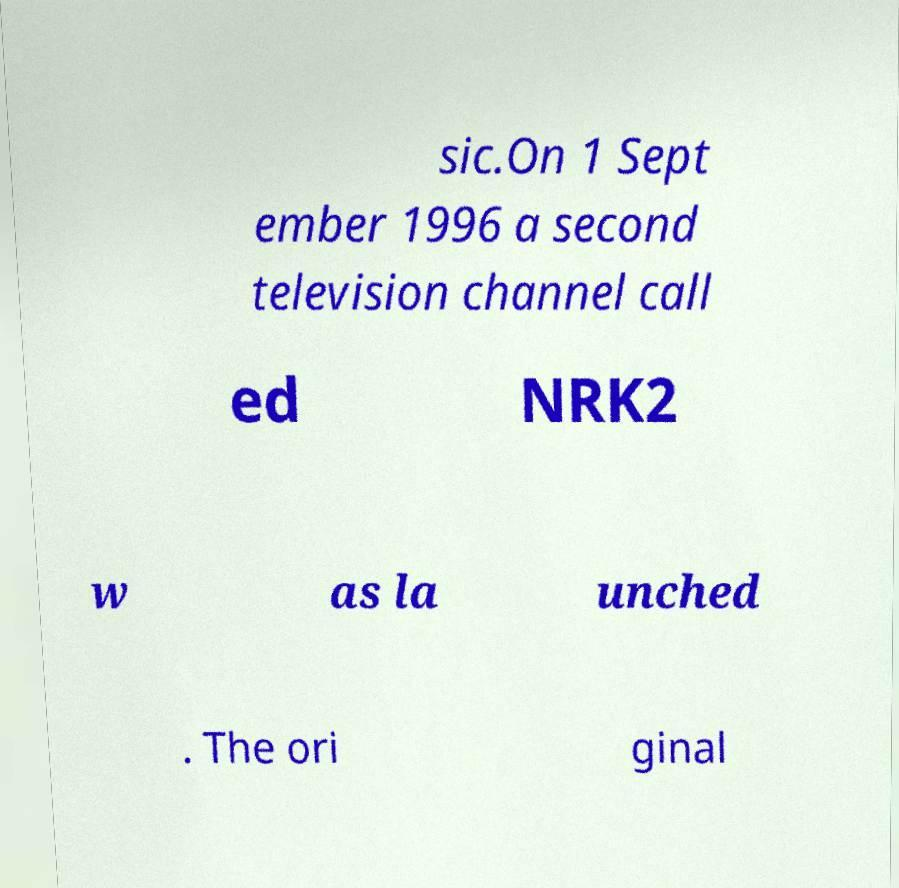I need the written content from this picture converted into text. Can you do that? sic.On 1 Sept ember 1996 a second television channel call ed NRK2 w as la unched . The ori ginal 